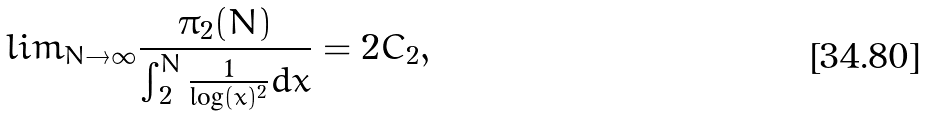<formula> <loc_0><loc_0><loc_500><loc_500>l i m _ { N \rightarrow \infty } \frac { \pi _ { 2 } ( N ) } { \int _ { 2 } ^ { N } \frac { 1 } { \log ( x ) ^ { 2 } } d x } = 2 C _ { 2 } ,</formula> 